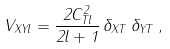Convert formula to latex. <formula><loc_0><loc_0><loc_500><loc_500>V _ { X Y l } = \frac { 2 C _ { T l } ^ { 2 } } { 2 l + 1 } \, \delta _ { X T } \, \delta _ { Y T } \, ,</formula> 